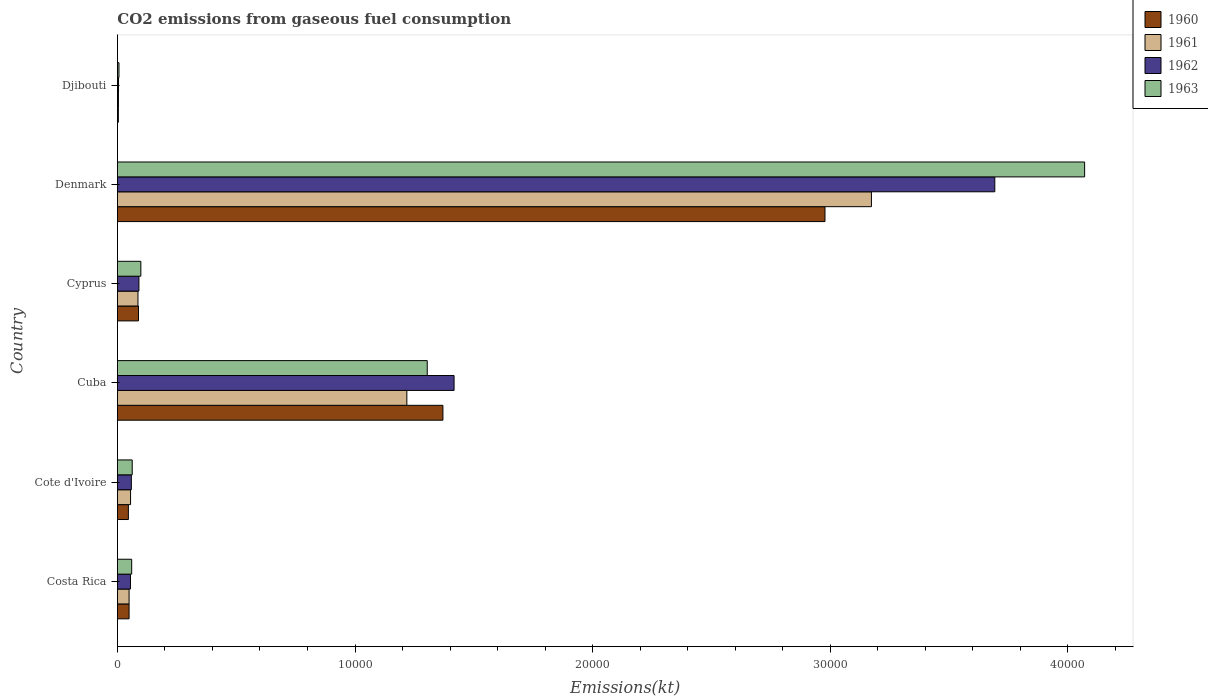How many different coloured bars are there?
Give a very brief answer. 4. Are the number of bars on each tick of the Y-axis equal?
Ensure brevity in your answer.  Yes. How many bars are there on the 4th tick from the bottom?
Provide a short and direct response. 4. What is the label of the 6th group of bars from the top?
Provide a short and direct response. Costa Rica. In how many cases, is the number of bars for a given country not equal to the number of legend labels?
Your answer should be very brief. 0. What is the amount of CO2 emitted in 1960 in Cyprus?
Ensure brevity in your answer.  887.41. Across all countries, what is the maximum amount of CO2 emitted in 1962?
Your response must be concise. 3.69e+04. Across all countries, what is the minimum amount of CO2 emitted in 1960?
Provide a succinct answer. 40.34. In which country was the amount of CO2 emitted in 1963 minimum?
Keep it short and to the point. Djibouti. What is the total amount of CO2 emitted in 1961 in the graph?
Your answer should be compact. 4.59e+04. What is the difference between the amount of CO2 emitted in 1960 in Costa Rica and that in Cuba?
Provide a short and direct response. -1.32e+04. What is the difference between the amount of CO2 emitted in 1961 in Cyprus and the amount of CO2 emitted in 1963 in Djibouti?
Offer a very short reply. 799.41. What is the average amount of CO2 emitted in 1961 per country?
Ensure brevity in your answer.  7645.08. What is the difference between the amount of CO2 emitted in 1960 and amount of CO2 emitted in 1962 in Denmark?
Your answer should be very brief. -7146.98. In how many countries, is the amount of CO2 emitted in 1962 greater than 8000 kt?
Ensure brevity in your answer.  2. What is the ratio of the amount of CO2 emitted in 1961 in Costa Rica to that in Cyprus?
Your answer should be compact. 0.57. Is the amount of CO2 emitted in 1963 in Costa Rica less than that in Cote d'Ivoire?
Provide a short and direct response. Yes. What is the difference between the highest and the second highest amount of CO2 emitted in 1963?
Keep it short and to the point. 2.77e+04. What is the difference between the highest and the lowest amount of CO2 emitted in 1962?
Your response must be concise. 3.69e+04. In how many countries, is the amount of CO2 emitted in 1960 greater than the average amount of CO2 emitted in 1960 taken over all countries?
Your response must be concise. 2. Is the sum of the amount of CO2 emitted in 1962 in Denmark and Djibouti greater than the maximum amount of CO2 emitted in 1961 across all countries?
Give a very brief answer. Yes. Is it the case that in every country, the sum of the amount of CO2 emitted in 1962 and amount of CO2 emitted in 1963 is greater than the sum of amount of CO2 emitted in 1960 and amount of CO2 emitted in 1961?
Offer a very short reply. No. What does the 3rd bar from the bottom in Cote d'Ivoire represents?
Ensure brevity in your answer.  1962. How many bars are there?
Give a very brief answer. 24. Does the graph contain any zero values?
Give a very brief answer. No. How are the legend labels stacked?
Give a very brief answer. Vertical. What is the title of the graph?
Your response must be concise. CO2 emissions from gaseous fuel consumption. Does "1982" appear as one of the legend labels in the graph?
Provide a short and direct response. No. What is the label or title of the X-axis?
Provide a short and direct response. Emissions(kt). What is the label or title of the Y-axis?
Keep it short and to the point. Country. What is the Emissions(kt) in 1960 in Costa Rica?
Keep it short and to the point. 491.38. What is the Emissions(kt) of 1961 in Costa Rica?
Offer a very short reply. 491.38. What is the Emissions(kt) of 1962 in Costa Rica?
Ensure brevity in your answer.  550.05. What is the Emissions(kt) in 1963 in Costa Rica?
Your answer should be very brief. 601.39. What is the Emissions(kt) in 1960 in Cote d'Ivoire?
Ensure brevity in your answer.  462.04. What is the Emissions(kt) of 1961 in Cote d'Ivoire?
Ensure brevity in your answer.  553.72. What is the Emissions(kt) of 1962 in Cote d'Ivoire?
Give a very brief answer. 586.72. What is the Emissions(kt) of 1963 in Cote d'Ivoire?
Your answer should be very brief. 623.39. What is the Emissions(kt) of 1960 in Cuba?
Ensure brevity in your answer.  1.37e+04. What is the Emissions(kt) in 1961 in Cuba?
Provide a short and direct response. 1.22e+04. What is the Emissions(kt) in 1962 in Cuba?
Make the answer very short. 1.42e+04. What is the Emissions(kt) of 1963 in Cuba?
Make the answer very short. 1.30e+04. What is the Emissions(kt) of 1960 in Cyprus?
Keep it short and to the point. 887.41. What is the Emissions(kt) in 1961 in Cyprus?
Your response must be concise. 865.41. What is the Emissions(kt) of 1962 in Cyprus?
Make the answer very short. 905.75. What is the Emissions(kt) of 1963 in Cyprus?
Keep it short and to the point. 986.42. What is the Emissions(kt) of 1960 in Denmark?
Keep it short and to the point. 2.98e+04. What is the Emissions(kt) in 1961 in Denmark?
Offer a terse response. 3.17e+04. What is the Emissions(kt) of 1962 in Denmark?
Your response must be concise. 3.69e+04. What is the Emissions(kt) in 1963 in Denmark?
Your answer should be very brief. 4.07e+04. What is the Emissions(kt) in 1960 in Djibouti?
Keep it short and to the point. 40.34. What is the Emissions(kt) of 1961 in Djibouti?
Keep it short and to the point. 44. What is the Emissions(kt) of 1962 in Djibouti?
Ensure brevity in your answer.  47.67. What is the Emissions(kt) in 1963 in Djibouti?
Your response must be concise. 66.01. Across all countries, what is the maximum Emissions(kt) of 1960?
Offer a terse response. 2.98e+04. Across all countries, what is the maximum Emissions(kt) in 1961?
Keep it short and to the point. 3.17e+04. Across all countries, what is the maximum Emissions(kt) of 1962?
Ensure brevity in your answer.  3.69e+04. Across all countries, what is the maximum Emissions(kt) of 1963?
Keep it short and to the point. 4.07e+04. Across all countries, what is the minimum Emissions(kt) of 1960?
Provide a succinct answer. 40.34. Across all countries, what is the minimum Emissions(kt) in 1961?
Offer a terse response. 44. Across all countries, what is the minimum Emissions(kt) in 1962?
Keep it short and to the point. 47.67. Across all countries, what is the minimum Emissions(kt) of 1963?
Your answer should be very brief. 66.01. What is the total Emissions(kt) in 1960 in the graph?
Keep it short and to the point. 4.54e+04. What is the total Emissions(kt) of 1961 in the graph?
Make the answer very short. 4.59e+04. What is the total Emissions(kt) of 1962 in the graph?
Your response must be concise. 5.32e+04. What is the total Emissions(kt) of 1963 in the graph?
Provide a short and direct response. 5.60e+04. What is the difference between the Emissions(kt) of 1960 in Costa Rica and that in Cote d'Ivoire?
Your answer should be very brief. 29.34. What is the difference between the Emissions(kt) of 1961 in Costa Rica and that in Cote d'Ivoire?
Give a very brief answer. -62.34. What is the difference between the Emissions(kt) in 1962 in Costa Rica and that in Cote d'Ivoire?
Your answer should be very brief. -36.67. What is the difference between the Emissions(kt) in 1963 in Costa Rica and that in Cote d'Ivoire?
Offer a very short reply. -22. What is the difference between the Emissions(kt) in 1960 in Costa Rica and that in Cuba?
Your response must be concise. -1.32e+04. What is the difference between the Emissions(kt) of 1961 in Costa Rica and that in Cuba?
Give a very brief answer. -1.17e+04. What is the difference between the Emissions(kt) of 1962 in Costa Rica and that in Cuba?
Give a very brief answer. -1.36e+04. What is the difference between the Emissions(kt) in 1963 in Costa Rica and that in Cuba?
Provide a short and direct response. -1.24e+04. What is the difference between the Emissions(kt) of 1960 in Costa Rica and that in Cyprus?
Give a very brief answer. -396.04. What is the difference between the Emissions(kt) of 1961 in Costa Rica and that in Cyprus?
Make the answer very short. -374.03. What is the difference between the Emissions(kt) of 1962 in Costa Rica and that in Cyprus?
Ensure brevity in your answer.  -355.7. What is the difference between the Emissions(kt) of 1963 in Costa Rica and that in Cyprus?
Your answer should be very brief. -385.04. What is the difference between the Emissions(kt) in 1960 in Costa Rica and that in Denmark?
Provide a succinct answer. -2.93e+04. What is the difference between the Emissions(kt) in 1961 in Costa Rica and that in Denmark?
Make the answer very short. -3.12e+04. What is the difference between the Emissions(kt) of 1962 in Costa Rica and that in Denmark?
Make the answer very short. -3.64e+04. What is the difference between the Emissions(kt) of 1963 in Costa Rica and that in Denmark?
Ensure brevity in your answer.  -4.01e+04. What is the difference between the Emissions(kt) of 1960 in Costa Rica and that in Djibouti?
Your answer should be compact. 451.04. What is the difference between the Emissions(kt) in 1961 in Costa Rica and that in Djibouti?
Your answer should be very brief. 447.37. What is the difference between the Emissions(kt) of 1962 in Costa Rica and that in Djibouti?
Your answer should be compact. 502.38. What is the difference between the Emissions(kt) of 1963 in Costa Rica and that in Djibouti?
Provide a short and direct response. 535.38. What is the difference between the Emissions(kt) of 1960 in Cote d'Ivoire and that in Cuba?
Provide a short and direct response. -1.32e+04. What is the difference between the Emissions(kt) in 1961 in Cote d'Ivoire and that in Cuba?
Provide a short and direct response. -1.16e+04. What is the difference between the Emissions(kt) in 1962 in Cote d'Ivoire and that in Cuba?
Offer a terse response. -1.36e+04. What is the difference between the Emissions(kt) of 1963 in Cote d'Ivoire and that in Cuba?
Ensure brevity in your answer.  -1.24e+04. What is the difference between the Emissions(kt) of 1960 in Cote d'Ivoire and that in Cyprus?
Give a very brief answer. -425.37. What is the difference between the Emissions(kt) of 1961 in Cote d'Ivoire and that in Cyprus?
Provide a succinct answer. -311.69. What is the difference between the Emissions(kt) of 1962 in Cote d'Ivoire and that in Cyprus?
Your answer should be very brief. -319.03. What is the difference between the Emissions(kt) of 1963 in Cote d'Ivoire and that in Cyprus?
Make the answer very short. -363.03. What is the difference between the Emissions(kt) in 1960 in Cote d'Ivoire and that in Denmark?
Your answer should be compact. -2.93e+04. What is the difference between the Emissions(kt) of 1961 in Cote d'Ivoire and that in Denmark?
Make the answer very short. -3.12e+04. What is the difference between the Emissions(kt) of 1962 in Cote d'Ivoire and that in Denmark?
Offer a very short reply. -3.63e+04. What is the difference between the Emissions(kt) of 1963 in Cote d'Ivoire and that in Denmark?
Your response must be concise. -4.01e+04. What is the difference between the Emissions(kt) in 1960 in Cote d'Ivoire and that in Djibouti?
Offer a very short reply. 421.7. What is the difference between the Emissions(kt) in 1961 in Cote d'Ivoire and that in Djibouti?
Ensure brevity in your answer.  509.71. What is the difference between the Emissions(kt) in 1962 in Cote d'Ivoire and that in Djibouti?
Your response must be concise. 539.05. What is the difference between the Emissions(kt) of 1963 in Cote d'Ivoire and that in Djibouti?
Offer a terse response. 557.38. What is the difference between the Emissions(kt) of 1960 in Cuba and that in Cyprus?
Provide a short and direct response. 1.28e+04. What is the difference between the Emissions(kt) in 1961 in Cuba and that in Cyprus?
Offer a very short reply. 1.13e+04. What is the difference between the Emissions(kt) in 1962 in Cuba and that in Cyprus?
Your answer should be very brief. 1.33e+04. What is the difference between the Emissions(kt) of 1963 in Cuba and that in Cyprus?
Your response must be concise. 1.21e+04. What is the difference between the Emissions(kt) of 1960 in Cuba and that in Denmark?
Make the answer very short. -1.61e+04. What is the difference between the Emissions(kt) in 1961 in Cuba and that in Denmark?
Offer a terse response. -1.96e+04. What is the difference between the Emissions(kt) of 1962 in Cuba and that in Denmark?
Ensure brevity in your answer.  -2.28e+04. What is the difference between the Emissions(kt) in 1963 in Cuba and that in Denmark?
Give a very brief answer. -2.77e+04. What is the difference between the Emissions(kt) in 1960 in Cuba and that in Djibouti?
Your answer should be very brief. 1.37e+04. What is the difference between the Emissions(kt) of 1961 in Cuba and that in Djibouti?
Your answer should be compact. 1.21e+04. What is the difference between the Emissions(kt) of 1962 in Cuba and that in Djibouti?
Offer a very short reply. 1.41e+04. What is the difference between the Emissions(kt) of 1963 in Cuba and that in Djibouti?
Ensure brevity in your answer.  1.30e+04. What is the difference between the Emissions(kt) of 1960 in Cyprus and that in Denmark?
Make the answer very short. -2.89e+04. What is the difference between the Emissions(kt) in 1961 in Cyprus and that in Denmark?
Your answer should be compact. -3.09e+04. What is the difference between the Emissions(kt) of 1962 in Cyprus and that in Denmark?
Offer a terse response. -3.60e+04. What is the difference between the Emissions(kt) in 1963 in Cyprus and that in Denmark?
Offer a terse response. -3.97e+04. What is the difference between the Emissions(kt) of 1960 in Cyprus and that in Djibouti?
Your answer should be very brief. 847.08. What is the difference between the Emissions(kt) of 1961 in Cyprus and that in Djibouti?
Make the answer very short. 821.41. What is the difference between the Emissions(kt) in 1962 in Cyprus and that in Djibouti?
Offer a terse response. 858.08. What is the difference between the Emissions(kt) of 1963 in Cyprus and that in Djibouti?
Give a very brief answer. 920.42. What is the difference between the Emissions(kt) in 1960 in Denmark and that in Djibouti?
Offer a very short reply. 2.97e+04. What is the difference between the Emissions(kt) of 1961 in Denmark and that in Djibouti?
Provide a succinct answer. 3.17e+04. What is the difference between the Emissions(kt) in 1962 in Denmark and that in Djibouti?
Your answer should be very brief. 3.69e+04. What is the difference between the Emissions(kt) of 1963 in Denmark and that in Djibouti?
Your answer should be compact. 4.06e+04. What is the difference between the Emissions(kt) in 1960 in Costa Rica and the Emissions(kt) in 1961 in Cote d'Ivoire?
Offer a very short reply. -62.34. What is the difference between the Emissions(kt) of 1960 in Costa Rica and the Emissions(kt) of 1962 in Cote d'Ivoire?
Offer a very short reply. -95.34. What is the difference between the Emissions(kt) in 1960 in Costa Rica and the Emissions(kt) in 1963 in Cote d'Ivoire?
Provide a succinct answer. -132.01. What is the difference between the Emissions(kt) of 1961 in Costa Rica and the Emissions(kt) of 1962 in Cote d'Ivoire?
Your response must be concise. -95.34. What is the difference between the Emissions(kt) in 1961 in Costa Rica and the Emissions(kt) in 1963 in Cote d'Ivoire?
Offer a very short reply. -132.01. What is the difference between the Emissions(kt) of 1962 in Costa Rica and the Emissions(kt) of 1963 in Cote d'Ivoire?
Provide a short and direct response. -73.34. What is the difference between the Emissions(kt) in 1960 in Costa Rica and the Emissions(kt) in 1961 in Cuba?
Offer a terse response. -1.17e+04. What is the difference between the Emissions(kt) of 1960 in Costa Rica and the Emissions(kt) of 1962 in Cuba?
Your answer should be very brief. -1.37e+04. What is the difference between the Emissions(kt) in 1960 in Costa Rica and the Emissions(kt) in 1963 in Cuba?
Provide a succinct answer. -1.25e+04. What is the difference between the Emissions(kt) of 1961 in Costa Rica and the Emissions(kt) of 1962 in Cuba?
Your answer should be very brief. -1.37e+04. What is the difference between the Emissions(kt) in 1961 in Costa Rica and the Emissions(kt) in 1963 in Cuba?
Ensure brevity in your answer.  -1.25e+04. What is the difference between the Emissions(kt) of 1962 in Costa Rica and the Emissions(kt) of 1963 in Cuba?
Your answer should be very brief. -1.25e+04. What is the difference between the Emissions(kt) of 1960 in Costa Rica and the Emissions(kt) of 1961 in Cyprus?
Offer a terse response. -374.03. What is the difference between the Emissions(kt) in 1960 in Costa Rica and the Emissions(kt) in 1962 in Cyprus?
Make the answer very short. -414.37. What is the difference between the Emissions(kt) in 1960 in Costa Rica and the Emissions(kt) in 1963 in Cyprus?
Ensure brevity in your answer.  -495.05. What is the difference between the Emissions(kt) of 1961 in Costa Rica and the Emissions(kt) of 1962 in Cyprus?
Provide a short and direct response. -414.37. What is the difference between the Emissions(kt) of 1961 in Costa Rica and the Emissions(kt) of 1963 in Cyprus?
Ensure brevity in your answer.  -495.05. What is the difference between the Emissions(kt) in 1962 in Costa Rica and the Emissions(kt) in 1963 in Cyprus?
Offer a very short reply. -436.37. What is the difference between the Emissions(kt) in 1960 in Costa Rica and the Emissions(kt) in 1961 in Denmark?
Provide a succinct answer. -3.12e+04. What is the difference between the Emissions(kt) of 1960 in Costa Rica and the Emissions(kt) of 1962 in Denmark?
Offer a very short reply. -3.64e+04. What is the difference between the Emissions(kt) in 1960 in Costa Rica and the Emissions(kt) in 1963 in Denmark?
Provide a succinct answer. -4.02e+04. What is the difference between the Emissions(kt) of 1961 in Costa Rica and the Emissions(kt) of 1962 in Denmark?
Your answer should be very brief. -3.64e+04. What is the difference between the Emissions(kt) of 1961 in Costa Rica and the Emissions(kt) of 1963 in Denmark?
Give a very brief answer. -4.02e+04. What is the difference between the Emissions(kt) of 1962 in Costa Rica and the Emissions(kt) of 1963 in Denmark?
Make the answer very short. -4.02e+04. What is the difference between the Emissions(kt) in 1960 in Costa Rica and the Emissions(kt) in 1961 in Djibouti?
Your response must be concise. 447.37. What is the difference between the Emissions(kt) of 1960 in Costa Rica and the Emissions(kt) of 1962 in Djibouti?
Ensure brevity in your answer.  443.71. What is the difference between the Emissions(kt) in 1960 in Costa Rica and the Emissions(kt) in 1963 in Djibouti?
Offer a very short reply. 425.37. What is the difference between the Emissions(kt) in 1961 in Costa Rica and the Emissions(kt) in 1962 in Djibouti?
Offer a terse response. 443.71. What is the difference between the Emissions(kt) of 1961 in Costa Rica and the Emissions(kt) of 1963 in Djibouti?
Keep it short and to the point. 425.37. What is the difference between the Emissions(kt) of 1962 in Costa Rica and the Emissions(kt) of 1963 in Djibouti?
Offer a very short reply. 484.04. What is the difference between the Emissions(kt) of 1960 in Cote d'Ivoire and the Emissions(kt) of 1961 in Cuba?
Your answer should be very brief. -1.17e+04. What is the difference between the Emissions(kt) of 1960 in Cote d'Ivoire and the Emissions(kt) of 1962 in Cuba?
Your answer should be compact. -1.37e+04. What is the difference between the Emissions(kt) in 1960 in Cote d'Ivoire and the Emissions(kt) in 1963 in Cuba?
Your answer should be very brief. -1.26e+04. What is the difference between the Emissions(kt) in 1961 in Cote d'Ivoire and the Emissions(kt) in 1962 in Cuba?
Your answer should be compact. -1.36e+04. What is the difference between the Emissions(kt) in 1961 in Cote d'Ivoire and the Emissions(kt) in 1963 in Cuba?
Offer a terse response. -1.25e+04. What is the difference between the Emissions(kt) in 1962 in Cote d'Ivoire and the Emissions(kt) in 1963 in Cuba?
Ensure brevity in your answer.  -1.25e+04. What is the difference between the Emissions(kt) in 1960 in Cote d'Ivoire and the Emissions(kt) in 1961 in Cyprus?
Ensure brevity in your answer.  -403.37. What is the difference between the Emissions(kt) in 1960 in Cote d'Ivoire and the Emissions(kt) in 1962 in Cyprus?
Your answer should be compact. -443.71. What is the difference between the Emissions(kt) of 1960 in Cote d'Ivoire and the Emissions(kt) of 1963 in Cyprus?
Make the answer very short. -524.38. What is the difference between the Emissions(kt) in 1961 in Cote d'Ivoire and the Emissions(kt) in 1962 in Cyprus?
Offer a very short reply. -352.03. What is the difference between the Emissions(kt) of 1961 in Cote d'Ivoire and the Emissions(kt) of 1963 in Cyprus?
Offer a very short reply. -432.71. What is the difference between the Emissions(kt) in 1962 in Cote d'Ivoire and the Emissions(kt) in 1963 in Cyprus?
Your answer should be very brief. -399.7. What is the difference between the Emissions(kt) of 1960 in Cote d'Ivoire and the Emissions(kt) of 1961 in Denmark?
Ensure brevity in your answer.  -3.13e+04. What is the difference between the Emissions(kt) in 1960 in Cote d'Ivoire and the Emissions(kt) in 1962 in Denmark?
Keep it short and to the point. -3.65e+04. What is the difference between the Emissions(kt) in 1960 in Cote d'Ivoire and the Emissions(kt) in 1963 in Denmark?
Keep it short and to the point. -4.02e+04. What is the difference between the Emissions(kt) of 1961 in Cote d'Ivoire and the Emissions(kt) of 1962 in Denmark?
Give a very brief answer. -3.64e+04. What is the difference between the Emissions(kt) in 1961 in Cote d'Ivoire and the Emissions(kt) in 1963 in Denmark?
Your answer should be compact. -4.02e+04. What is the difference between the Emissions(kt) of 1962 in Cote d'Ivoire and the Emissions(kt) of 1963 in Denmark?
Your response must be concise. -4.01e+04. What is the difference between the Emissions(kt) of 1960 in Cote d'Ivoire and the Emissions(kt) of 1961 in Djibouti?
Provide a short and direct response. 418.04. What is the difference between the Emissions(kt) in 1960 in Cote d'Ivoire and the Emissions(kt) in 1962 in Djibouti?
Keep it short and to the point. 414.37. What is the difference between the Emissions(kt) of 1960 in Cote d'Ivoire and the Emissions(kt) of 1963 in Djibouti?
Give a very brief answer. 396.04. What is the difference between the Emissions(kt) in 1961 in Cote d'Ivoire and the Emissions(kt) in 1962 in Djibouti?
Ensure brevity in your answer.  506.05. What is the difference between the Emissions(kt) in 1961 in Cote d'Ivoire and the Emissions(kt) in 1963 in Djibouti?
Offer a very short reply. 487.71. What is the difference between the Emissions(kt) of 1962 in Cote d'Ivoire and the Emissions(kt) of 1963 in Djibouti?
Offer a very short reply. 520.71. What is the difference between the Emissions(kt) of 1960 in Cuba and the Emissions(kt) of 1961 in Cyprus?
Provide a short and direct response. 1.28e+04. What is the difference between the Emissions(kt) in 1960 in Cuba and the Emissions(kt) in 1962 in Cyprus?
Your answer should be compact. 1.28e+04. What is the difference between the Emissions(kt) of 1960 in Cuba and the Emissions(kt) of 1963 in Cyprus?
Keep it short and to the point. 1.27e+04. What is the difference between the Emissions(kt) in 1961 in Cuba and the Emissions(kt) in 1962 in Cyprus?
Your response must be concise. 1.13e+04. What is the difference between the Emissions(kt) in 1961 in Cuba and the Emissions(kt) in 1963 in Cyprus?
Offer a very short reply. 1.12e+04. What is the difference between the Emissions(kt) of 1962 in Cuba and the Emissions(kt) of 1963 in Cyprus?
Your answer should be compact. 1.32e+04. What is the difference between the Emissions(kt) of 1960 in Cuba and the Emissions(kt) of 1961 in Denmark?
Give a very brief answer. -1.80e+04. What is the difference between the Emissions(kt) in 1960 in Cuba and the Emissions(kt) in 1962 in Denmark?
Your answer should be very brief. -2.32e+04. What is the difference between the Emissions(kt) in 1960 in Cuba and the Emissions(kt) in 1963 in Denmark?
Provide a short and direct response. -2.70e+04. What is the difference between the Emissions(kt) of 1961 in Cuba and the Emissions(kt) of 1962 in Denmark?
Your answer should be compact. -2.47e+04. What is the difference between the Emissions(kt) in 1961 in Cuba and the Emissions(kt) in 1963 in Denmark?
Your response must be concise. -2.85e+04. What is the difference between the Emissions(kt) of 1962 in Cuba and the Emissions(kt) of 1963 in Denmark?
Offer a terse response. -2.65e+04. What is the difference between the Emissions(kt) in 1960 in Cuba and the Emissions(kt) in 1961 in Djibouti?
Offer a very short reply. 1.37e+04. What is the difference between the Emissions(kt) in 1960 in Cuba and the Emissions(kt) in 1962 in Djibouti?
Offer a terse response. 1.37e+04. What is the difference between the Emissions(kt) of 1960 in Cuba and the Emissions(kt) of 1963 in Djibouti?
Make the answer very short. 1.36e+04. What is the difference between the Emissions(kt) in 1961 in Cuba and the Emissions(kt) in 1962 in Djibouti?
Your answer should be compact. 1.21e+04. What is the difference between the Emissions(kt) of 1961 in Cuba and the Emissions(kt) of 1963 in Djibouti?
Provide a succinct answer. 1.21e+04. What is the difference between the Emissions(kt) in 1962 in Cuba and the Emissions(kt) in 1963 in Djibouti?
Your response must be concise. 1.41e+04. What is the difference between the Emissions(kt) in 1960 in Cyprus and the Emissions(kt) in 1961 in Denmark?
Your answer should be very brief. -3.08e+04. What is the difference between the Emissions(kt) of 1960 in Cyprus and the Emissions(kt) of 1962 in Denmark?
Offer a very short reply. -3.60e+04. What is the difference between the Emissions(kt) in 1960 in Cyprus and the Emissions(kt) in 1963 in Denmark?
Keep it short and to the point. -3.98e+04. What is the difference between the Emissions(kt) of 1961 in Cyprus and the Emissions(kt) of 1962 in Denmark?
Give a very brief answer. -3.61e+04. What is the difference between the Emissions(kt) of 1961 in Cyprus and the Emissions(kt) of 1963 in Denmark?
Ensure brevity in your answer.  -3.98e+04. What is the difference between the Emissions(kt) of 1962 in Cyprus and the Emissions(kt) of 1963 in Denmark?
Keep it short and to the point. -3.98e+04. What is the difference between the Emissions(kt) of 1960 in Cyprus and the Emissions(kt) of 1961 in Djibouti?
Your answer should be very brief. 843.41. What is the difference between the Emissions(kt) in 1960 in Cyprus and the Emissions(kt) in 1962 in Djibouti?
Offer a very short reply. 839.74. What is the difference between the Emissions(kt) of 1960 in Cyprus and the Emissions(kt) of 1963 in Djibouti?
Ensure brevity in your answer.  821.41. What is the difference between the Emissions(kt) in 1961 in Cyprus and the Emissions(kt) in 1962 in Djibouti?
Offer a very short reply. 817.74. What is the difference between the Emissions(kt) of 1961 in Cyprus and the Emissions(kt) of 1963 in Djibouti?
Your response must be concise. 799.41. What is the difference between the Emissions(kt) of 1962 in Cyprus and the Emissions(kt) of 1963 in Djibouti?
Provide a succinct answer. 839.74. What is the difference between the Emissions(kt) in 1960 in Denmark and the Emissions(kt) in 1961 in Djibouti?
Provide a succinct answer. 2.97e+04. What is the difference between the Emissions(kt) of 1960 in Denmark and the Emissions(kt) of 1962 in Djibouti?
Make the answer very short. 2.97e+04. What is the difference between the Emissions(kt) in 1960 in Denmark and the Emissions(kt) in 1963 in Djibouti?
Provide a short and direct response. 2.97e+04. What is the difference between the Emissions(kt) of 1961 in Denmark and the Emissions(kt) of 1962 in Djibouti?
Your answer should be very brief. 3.17e+04. What is the difference between the Emissions(kt) of 1961 in Denmark and the Emissions(kt) of 1963 in Djibouti?
Offer a terse response. 3.17e+04. What is the difference between the Emissions(kt) of 1962 in Denmark and the Emissions(kt) of 1963 in Djibouti?
Make the answer very short. 3.69e+04. What is the average Emissions(kt) of 1960 per country?
Offer a terse response. 7560.13. What is the average Emissions(kt) in 1961 per country?
Ensure brevity in your answer.  7645.08. What is the average Emissions(kt) in 1962 per country?
Give a very brief answer. 8864.36. What is the average Emissions(kt) in 1963 per country?
Your response must be concise. 9337.4. What is the difference between the Emissions(kt) in 1960 and Emissions(kt) in 1962 in Costa Rica?
Make the answer very short. -58.67. What is the difference between the Emissions(kt) of 1960 and Emissions(kt) of 1963 in Costa Rica?
Provide a short and direct response. -110.01. What is the difference between the Emissions(kt) in 1961 and Emissions(kt) in 1962 in Costa Rica?
Make the answer very short. -58.67. What is the difference between the Emissions(kt) of 1961 and Emissions(kt) of 1963 in Costa Rica?
Provide a short and direct response. -110.01. What is the difference between the Emissions(kt) in 1962 and Emissions(kt) in 1963 in Costa Rica?
Give a very brief answer. -51.34. What is the difference between the Emissions(kt) of 1960 and Emissions(kt) of 1961 in Cote d'Ivoire?
Your answer should be very brief. -91.67. What is the difference between the Emissions(kt) of 1960 and Emissions(kt) of 1962 in Cote d'Ivoire?
Your answer should be very brief. -124.68. What is the difference between the Emissions(kt) of 1960 and Emissions(kt) of 1963 in Cote d'Ivoire?
Provide a short and direct response. -161.35. What is the difference between the Emissions(kt) in 1961 and Emissions(kt) in 1962 in Cote d'Ivoire?
Offer a very short reply. -33. What is the difference between the Emissions(kt) in 1961 and Emissions(kt) in 1963 in Cote d'Ivoire?
Ensure brevity in your answer.  -69.67. What is the difference between the Emissions(kt) of 1962 and Emissions(kt) of 1963 in Cote d'Ivoire?
Your answer should be very brief. -36.67. What is the difference between the Emissions(kt) of 1960 and Emissions(kt) of 1961 in Cuba?
Your response must be concise. 1518.14. What is the difference between the Emissions(kt) in 1960 and Emissions(kt) in 1962 in Cuba?
Give a very brief answer. -469.38. What is the difference between the Emissions(kt) in 1960 and Emissions(kt) in 1963 in Cuba?
Make the answer very short. 660.06. What is the difference between the Emissions(kt) of 1961 and Emissions(kt) of 1962 in Cuba?
Give a very brief answer. -1987.51. What is the difference between the Emissions(kt) in 1961 and Emissions(kt) in 1963 in Cuba?
Make the answer very short. -858.08. What is the difference between the Emissions(kt) in 1962 and Emissions(kt) in 1963 in Cuba?
Offer a terse response. 1129.44. What is the difference between the Emissions(kt) in 1960 and Emissions(kt) in 1961 in Cyprus?
Make the answer very short. 22. What is the difference between the Emissions(kt) of 1960 and Emissions(kt) of 1962 in Cyprus?
Make the answer very short. -18.34. What is the difference between the Emissions(kt) of 1960 and Emissions(kt) of 1963 in Cyprus?
Provide a succinct answer. -99.01. What is the difference between the Emissions(kt) of 1961 and Emissions(kt) of 1962 in Cyprus?
Your response must be concise. -40.34. What is the difference between the Emissions(kt) in 1961 and Emissions(kt) in 1963 in Cyprus?
Your answer should be compact. -121.01. What is the difference between the Emissions(kt) in 1962 and Emissions(kt) in 1963 in Cyprus?
Give a very brief answer. -80.67. What is the difference between the Emissions(kt) in 1960 and Emissions(kt) in 1961 in Denmark?
Your answer should be compact. -1954.51. What is the difference between the Emissions(kt) of 1960 and Emissions(kt) of 1962 in Denmark?
Offer a terse response. -7146.98. What is the difference between the Emissions(kt) of 1960 and Emissions(kt) of 1963 in Denmark?
Ensure brevity in your answer.  -1.09e+04. What is the difference between the Emissions(kt) in 1961 and Emissions(kt) in 1962 in Denmark?
Provide a succinct answer. -5192.47. What is the difference between the Emissions(kt) in 1961 and Emissions(kt) in 1963 in Denmark?
Offer a terse response. -8973.15. What is the difference between the Emissions(kt) in 1962 and Emissions(kt) in 1963 in Denmark?
Give a very brief answer. -3780.68. What is the difference between the Emissions(kt) in 1960 and Emissions(kt) in 1961 in Djibouti?
Provide a succinct answer. -3.67. What is the difference between the Emissions(kt) of 1960 and Emissions(kt) of 1962 in Djibouti?
Make the answer very short. -7.33. What is the difference between the Emissions(kt) of 1960 and Emissions(kt) of 1963 in Djibouti?
Keep it short and to the point. -25.67. What is the difference between the Emissions(kt) in 1961 and Emissions(kt) in 1962 in Djibouti?
Ensure brevity in your answer.  -3.67. What is the difference between the Emissions(kt) in 1961 and Emissions(kt) in 1963 in Djibouti?
Your answer should be very brief. -22. What is the difference between the Emissions(kt) in 1962 and Emissions(kt) in 1963 in Djibouti?
Provide a succinct answer. -18.34. What is the ratio of the Emissions(kt) of 1960 in Costa Rica to that in Cote d'Ivoire?
Offer a terse response. 1.06. What is the ratio of the Emissions(kt) in 1961 in Costa Rica to that in Cote d'Ivoire?
Give a very brief answer. 0.89. What is the ratio of the Emissions(kt) of 1963 in Costa Rica to that in Cote d'Ivoire?
Provide a succinct answer. 0.96. What is the ratio of the Emissions(kt) of 1960 in Costa Rica to that in Cuba?
Offer a terse response. 0.04. What is the ratio of the Emissions(kt) of 1961 in Costa Rica to that in Cuba?
Offer a very short reply. 0.04. What is the ratio of the Emissions(kt) of 1962 in Costa Rica to that in Cuba?
Provide a succinct answer. 0.04. What is the ratio of the Emissions(kt) of 1963 in Costa Rica to that in Cuba?
Keep it short and to the point. 0.05. What is the ratio of the Emissions(kt) in 1960 in Costa Rica to that in Cyprus?
Give a very brief answer. 0.55. What is the ratio of the Emissions(kt) in 1961 in Costa Rica to that in Cyprus?
Make the answer very short. 0.57. What is the ratio of the Emissions(kt) of 1962 in Costa Rica to that in Cyprus?
Offer a terse response. 0.61. What is the ratio of the Emissions(kt) of 1963 in Costa Rica to that in Cyprus?
Offer a very short reply. 0.61. What is the ratio of the Emissions(kt) in 1960 in Costa Rica to that in Denmark?
Provide a succinct answer. 0.02. What is the ratio of the Emissions(kt) in 1961 in Costa Rica to that in Denmark?
Ensure brevity in your answer.  0.02. What is the ratio of the Emissions(kt) of 1962 in Costa Rica to that in Denmark?
Offer a very short reply. 0.01. What is the ratio of the Emissions(kt) in 1963 in Costa Rica to that in Denmark?
Your answer should be compact. 0.01. What is the ratio of the Emissions(kt) of 1960 in Costa Rica to that in Djibouti?
Your answer should be very brief. 12.18. What is the ratio of the Emissions(kt) in 1961 in Costa Rica to that in Djibouti?
Provide a short and direct response. 11.17. What is the ratio of the Emissions(kt) of 1962 in Costa Rica to that in Djibouti?
Your response must be concise. 11.54. What is the ratio of the Emissions(kt) in 1963 in Costa Rica to that in Djibouti?
Your answer should be very brief. 9.11. What is the ratio of the Emissions(kt) of 1960 in Cote d'Ivoire to that in Cuba?
Keep it short and to the point. 0.03. What is the ratio of the Emissions(kt) of 1961 in Cote d'Ivoire to that in Cuba?
Your answer should be compact. 0.05. What is the ratio of the Emissions(kt) of 1962 in Cote d'Ivoire to that in Cuba?
Provide a short and direct response. 0.04. What is the ratio of the Emissions(kt) of 1963 in Cote d'Ivoire to that in Cuba?
Your answer should be compact. 0.05. What is the ratio of the Emissions(kt) in 1960 in Cote d'Ivoire to that in Cyprus?
Your response must be concise. 0.52. What is the ratio of the Emissions(kt) in 1961 in Cote d'Ivoire to that in Cyprus?
Offer a terse response. 0.64. What is the ratio of the Emissions(kt) in 1962 in Cote d'Ivoire to that in Cyprus?
Keep it short and to the point. 0.65. What is the ratio of the Emissions(kt) in 1963 in Cote d'Ivoire to that in Cyprus?
Offer a terse response. 0.63. What is the ratio of the Emissions(kt) in 1960 in Cote d'Ivoire to that in Denmark?
Offer a very short reply. 0.02. What is the ratio of the Emissions(kt) in 1961 in Cote d'Ivoire to that in Denmark?
Keep it short and to the point. 0.02. What is the ratio of the Emissions(kt) of 1962 in Cote d'Ivoire to that in Denmark?
Keep it short and to the point. 0.02. What is the ratio of the Emissions(kt) in 1963 in Cote d'Ivoire to that in Denmark?
Ensure brevity in your answer.  0.02. What is the ratio of the Emissions(kt) of 1960 in Cote d'Ivoire to that in Djibouti?
Offer a terse response. 11.45. What is the ratio of the Emissions(kt) of 1961 in Cote d'Ivoire to that in Djibouti?
Your response must be concise. 12.58. What is the ratio of the Emissions(kt) of 1962 in Cote d'Ivoire to that in Djibouti?
Provide a short and direct response. 12.31. What is the ratio of the Emissions(kt) of 1963 in Cote d'Ivoire to that in Djibouti?
Provide a succinct answer. 9.44. What is the ratio of the Emissions(kt) in 1960 in Cuba to that in Cyprus?
Give a very brief answer. 15.44. What is the ratio of the Emissions(kt) of 1961 in Cuba to that in Cyprus?
Provide a succinct answer. 14.08. What is the ratio of the Emissions(kt) of 1962 in Cuba to that in Cyprus?
Your response must be concise. 15.64. What is the ratio of the Emissions(kt) of 1963 in Cuba to that in Cyprus?
Make the answer very short. 13.22. What is the ratio of the Emissions(kt) of 1960 in Cuba to that in Denmark?
Provide a succinct answer. 0.46. What is the ratio of the Emissions(kt) of 1961 in Cuba to that in Denmark?
Keep it short and to the point. 0.38. What is the ratio of the Emissions(kt) of 1962 in Cuba to that in Denmark?
Keep it short and to the point. 0.38. What is the ratio of the Emissions(kt) in 1963 in Cuba to that in Denmark?
Provide a succinct answer. 0.32. What is the ratio of the Emissions(kt) of 1960 in Cuba to that in Djibouti?
Offer a very short reply. 339.64. What is the ratio of the Emissions(kt) in 1961 in Cuba to that in Djibouti?
Provide a short and direct response. 276.83. What is the ratio of the Emissions(kt) in 1962 in Cuba to that in Djibouti?
Your answer should be very brief. 297.23. What is the ratio of the Emissions(kt) of 1963 in Cuba to that in Djibouti?
Offer a very short reply. 197.56. What is the ratio of the Emissions(kt) in 1960 in Cyprus to that in Denmark?
Make the answer very short. 0.03. What is the ratio of the Emissions(kt) in 1961 in Cyprus to that in Denmark?
Your answer should be very brief. 0.03. What is the ratio of the Emissions(kt) of 1962 in Cyprus to that in Denmark?
Provide a succinct answer. 0.02. What is the ratio of the Emissions(kt) in 1963 in Cyprus to that in Denmark?
Provide a short and direct response. 0.02. What is the ratio of the Emissions(kt) in 1960 in Cyprus to that in Djibouti?
Make the answer very short. 22. What is the ratio of the Emissions(kt) in 1961 in Cyprus to that in Djibouti?
Your response must be concise. 19.67. What is the ratio of the Emissions(kt) in 1963 in Cyprus to that in Djibouti?
Provide a succinct answer. 14.94. What is the ratio of the Emissions(kt) of 1960 in Denmark to that in Djibouti?
Your answer should be very brief. 738.27. What is the ratio of the Emissions(kt) in 1961 in Denmark to that in Djibouti?
Ensure brevity in your answer.  721.17. What is the ratio of the Emissions(kt) in 1962 in Denmark to that in Djibouti?
Provide a succinct answer. 774.62. What is the ratio of the Emissions(kt) in 1963 in Denmark to that in Djibouti?
Your response must be concise. 616.72. What is the difference between the highest and the second highest Emissions(kt) of 1960?
Keep it short and to the point. 1.61e+04. What is the difference between the highest and the second highest Emissions(kt) of 1961?
Your answer should be compact. 1.96e+04. What is the difference between the highest and the second highest Emissions(kt) of 1962?
Provide a short and direct response. 2.28e+04. What is the difference between the highest and the second highest Emissions(kt) of 1963?
Keep it short and to the point. 2.77e+04. What is the difference between the highest and the lowest Emissions(kt) of 1960?
Give a very brief answer. 2.97e+04. What is the difference between the highest and the lowest Emissions(kt) in 1961?
Provide a short and direct response. 3.17e+04. What is the difference between the highest and the lowest Emissions(kt) of 1962?
Give a very brief answer. 3.69e+04. What is the difference between the highest and the lowest Emissions(kt) in 1963?
Your answer should be very brief. 4.06e+04. 